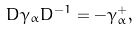Convert formula to latex. <formula><loc_0><loc_0><loc_500><loc_500>D \gamma _ { \alpha } D ^ { - 1 } = - \gamma _ { \alpha } ^ { + } ,</formula> 